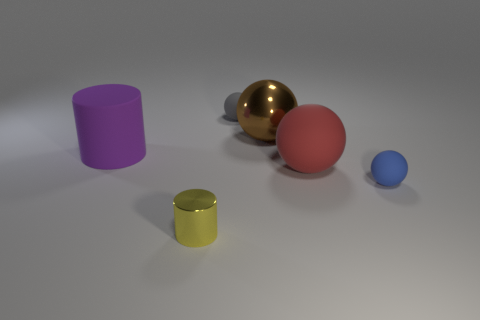Add 4 brown metal objects. How many objects exist? 10 Subtract all cylinders. How many objects are left? 4 Subtract all tiny yellow metal things. Subtract all cylinders. How many objects are left? 3 Add 1 tiny metal cylinders. How many tiny metal cylinders are left? 2 Add 5 yellow cylinders. How many yellow cylinders exist? 6 Subtract 0 cyan balls. How many objects are left? 6 